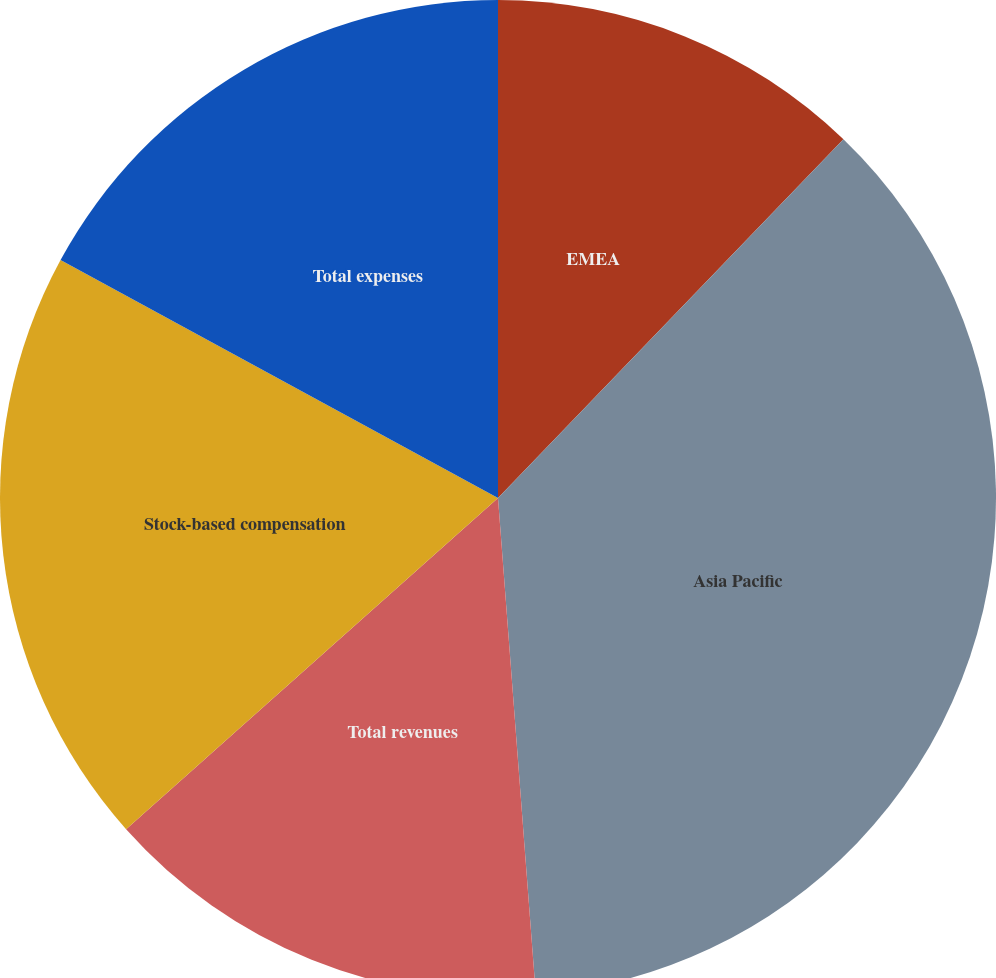Convert chart. <chart><loc_0><loc_0><loc_500><loc_500><pie_chart><fcel>EMEA<fcel>Asia Pacific<fcel>Total revenues<fcel>Stock-based compensation<fcel>Total expenses<nl><fcel>12.2%<fcel>36.59%<fcel>14.63%<fcel>19.51%<fcel>17.07%<nl></chart> 